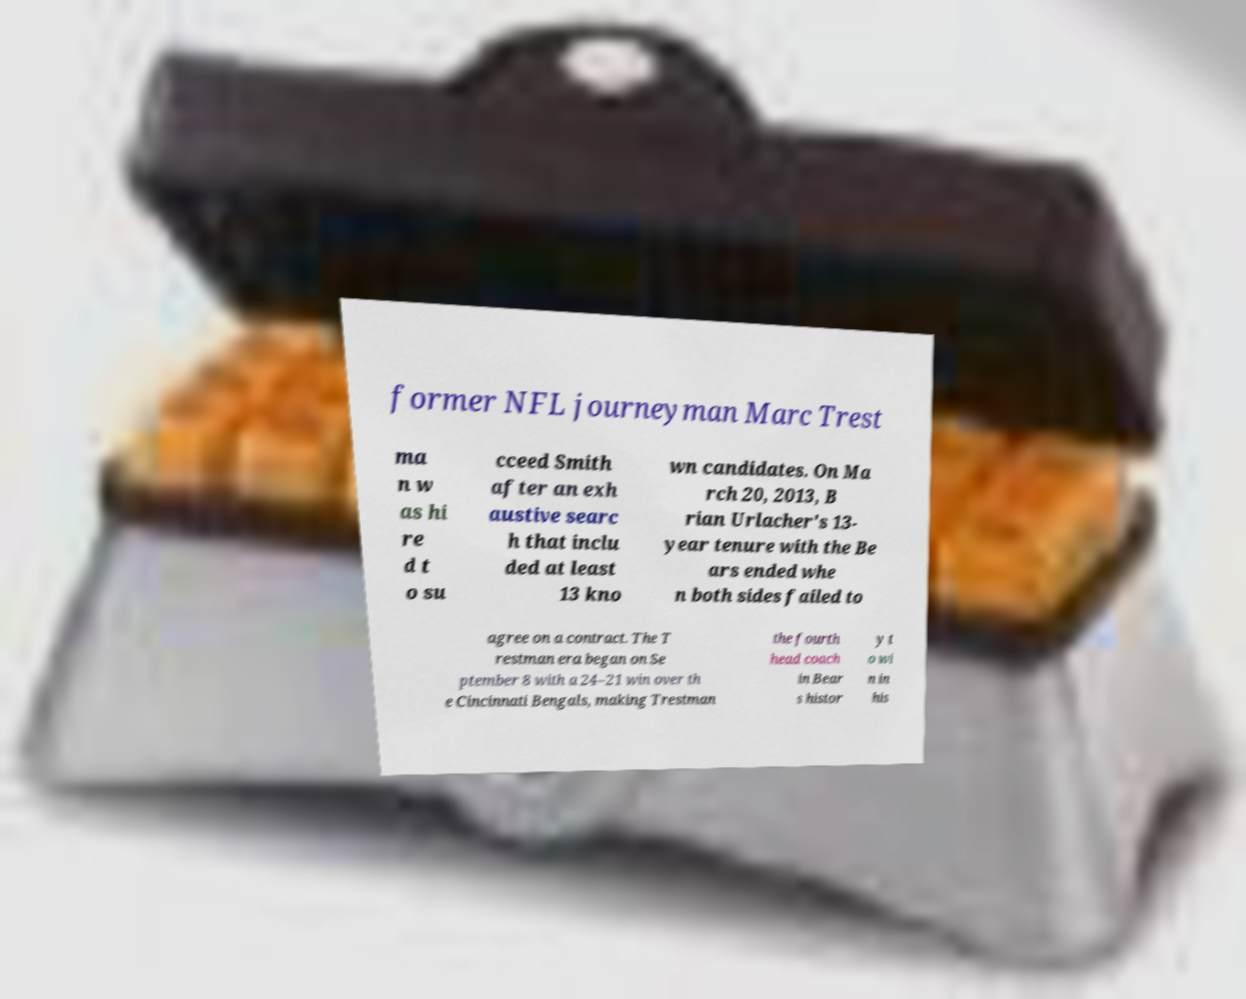Could you assist in decoding the text presented in this image and type it out clearly? former NFL journeyman Marc Trest ma n w as hi re d t o su cceed Smith after an exh austive searc h that inclu ded at least 13 kno wn candidates. On Ma rch 20, 2013, B rian Urlacher's 13- year tenure with the Be ars ended whe n both sides failed to agree on a contract. The T restman era began on Se ptember 8 with a 24–21 win over th e Cincinnati Bengals, making Trestman the fourth head coach in Bear s histor y t o wi n in his 